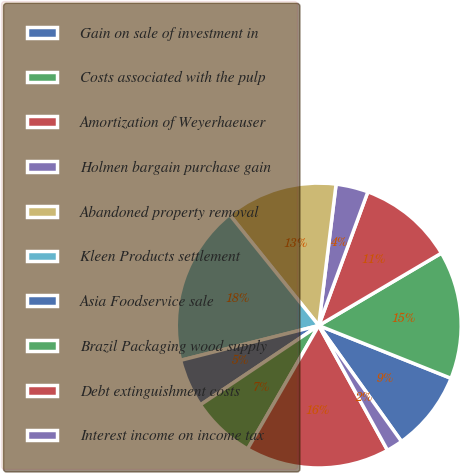Convert chart. <chart><loc_0><loc_0><loc_500><loc_500><pie_chart><fcel>Gain on sale of investment in<fcel>Costs associated with the pulp<fcel>Amortization of Weyerhaeuser<fcel>Holmen bargain purchase gain<fcel>Abandoned property removal<fcel>Kleen Products settlement<fcel>Asia Foodservice sale<fcel>Brazil Packaging wood supply<fcel>Debt extinguishment costs<fcel>Interest income on income tax<nl><fcel>9.09%<fcel>14.53%<fcel>10.91%<fcel>3.66%<fcel>12.72%<fcel>18.15%<fcel>5.47%<fcel>7.28%<fcel>16.34%<fcel>1.85%<nl></chart> 